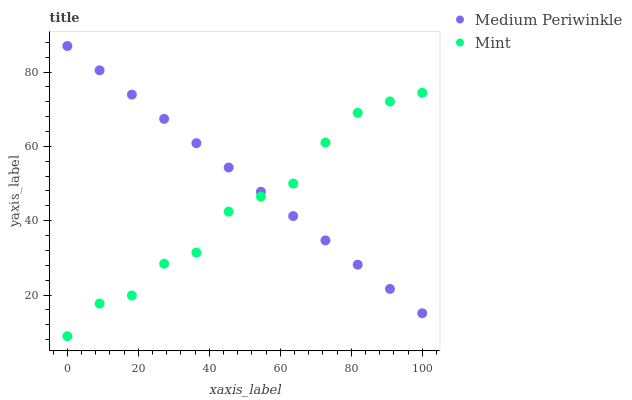Does Mint have the minimum area under the curve?
Answer yes or no. Yes. Does Medium Periwinkle have the maximum area under the curve?
Answer yes or no. Yes. Does Medium Periwinkle have the minimum area under the curve?
Answer yes or no. No. Is Medium Periwinkle the smoothest?
Answer yes or no. Yes. Is Mint the roughest?
Answer yes or no. Yes. Is Medium Periwinkle the roughest?
Answer yes or no. No. Does Mint have the lowest value?
Answer yes or no. Yes. Does Medium Periwinkle have the lowest value?
Answer yes or no. No. Does Medium Periwinkle have the highest value?
Answer yes or no. Yes. Does Medium Periwinkle intersect Mint?
Answer yes or no. Yes. Is Medium Periwinkle less than Mint?
Answer yes or no. No. Is Medium Periwinkle greater than Mint?
Answer yes or no. No. 